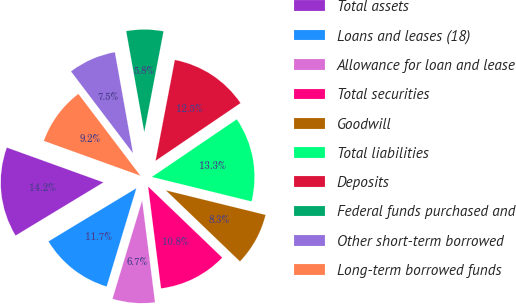Convert chart to OTSL. <chart><loc_0><loc_0><loc_500><loc_500><pie_chart><fcel>Total assets<fcel>Loans and leases (18)<fcel>Allowance for loan and lease<fcel>Total securities<fcel>Goodwill<fcel>Total liabilities<fcel>Deposits<fcel>Federal funds purchased and<fcel>Other short-term borrowed<fcel>Long-term borrowed funds<nl><fcel>14.17%<fcel>11.67%<fcel>6.67%<fcel>10.83%<fcel>8.33%<fcel>13.33%<fcel>12.5%<fcel>5.83%<fcel>7.5%<fcel>9.17%<nl></chart> 